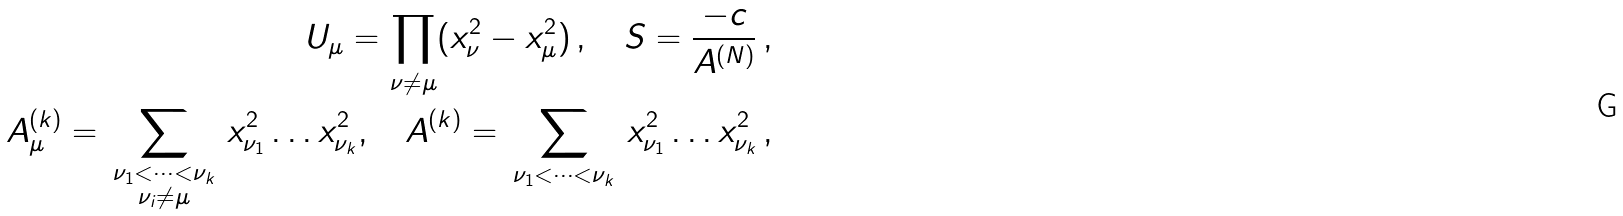Convert formula to latex. <formula><loc_0><loc_0><loc_500><loc_500>U _ { \mu } = \prod _ { \nu \ne \mu } ( x _ { \nu } ^ { 2 } - x _ { \mu } ^ { 2 } ) \, , \quad S = \frac { - c } { A ^ { ( N ) } } \, , \\ A ^ { ( k ) } _ { \mu } = \, \sum _ { \substack { \nu _ { 1 } < \dots < \nu _ { k } \\ \nu _ { i } \ne \mu } } \, x ^ { 2 } _ { \nu _ { 1 } } \dots x ^ { 2 } _ { \nu _ { k } } , \quad A ^ { ( k ) } = \, \sum _ { \nu _ { 1 } < \dots < \nu _ { k } } \, x ^ { 2 } _ { \nu _ { 1 } } \dots x ^ { 2 } _ { \nu _ { k } } \, ,</formula> 